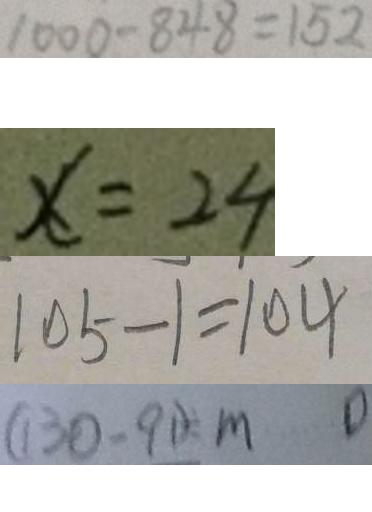Convert formula to latex. <formula><loc_0><loc_0><loc_500><loc_500>1 0 0 0 - 8 4 8 = 1 5 2 
 x = 2 4 
 1 0 5 - 1 = 1 0 4 
 ( 1 3 0 - 9 1 ) \div m 0</formula> 